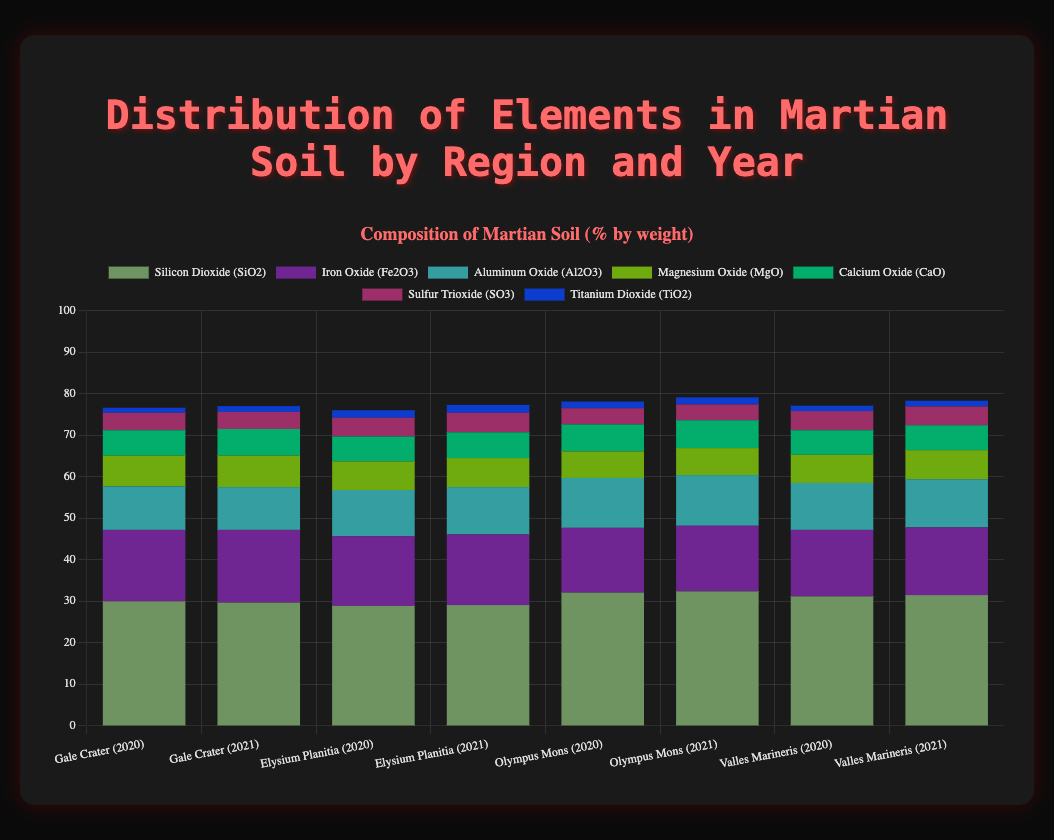What region and year have the highest percentage of Silicon Dioxide (SiO2)? Observing the bars in the figure, we look for the highest segment representing Silicon Dioxide (SiO2) across all regions and years. Olympus Mons in 2021 shows the highest percentage of Silicon Dioxide at 32.4%.
Answer: Olympus Mons, 2021 Which region has the most consistent percentage of Iron Oxide (Fe2O3) over the years? By checking the height of the Iron Oxide (Fe2O3) segments in all regions, we notice small variations in values for each region. Gale Crater has the most consistent percentages, with 17.2% in 2020 and 17.5% in 2021.
Answer: Gale Crater What is the total percentage of Magnesium Oxide (MgO) in Valles Marineris for both years combined? Summing up Magnesium Oxide (MgO) values in Valles Marineris for 2020 and 2021, we have 6.8% (2020) + 7.0% (2021) = 13.8%.
Answer: 13.8% Which region and year have the lowest percentage of Sulfur Trioxide (SO3)? Comparing the height of Sulfur Trioxide (SO3) segments across all bars, Olympus Mons in 2021 shows the lowest percentage at 3.8%.
Answer: Olympus Mons, 2021 By how much did the Aluminum Oxide (Al2O3) percentage change in Elysium Planitia from 2020 to 2021? Subtract the Aluminum Oxide (Al2O3) percentage in 2020 (11.1%) from the percentage in 2021 (11.4%). The change is 11.4% - 11.1% = 0.3%.
Answer: 0.3% What is the mean percentage of Calcium Oxide (CaO) in all regions for 2021? Calculate the mean by summing the Calcium Oxide (CaO) percentages for all regions in 2021 and dividing by the number of regions. The sum is 6.4% + 6.2% + 6.7% + 6.0% = 25.3%, and the mean is 25.3% / 4 = 6.325%.
Answer: 6.325% Which element has the highest mean percentage across all regions and years? Calculate the mean for each element by summing their percentages across all regions and years, then divide by the total number of observations (8). Silicon Dioxide (SiO2) has the highest mean at 30.7%.
Answer: Silicon Dioxide (SiO2) What is the combined percentage of Titanium Dioxide (TiO2) in Olympus Mons for both years? Add the Titanium Dioxide (TiO2) values in Olympus Mons for 2020 (1.6%) and 2021 (1.7%). The combined percentage is 1.6% + 1.7% = 3.3%.
Answer: 3.3% Compare the percentage of Silicon Dioxide (SiO2) in Valles Marineris between 2020 and 2021. Is there an increase or decrease? Check the Silicon Dioxide (SiO2) percentages for Valles Marineris in 2020 (31.2%) and 2021 (31.5%). There is an increase of 31.5% - 31.2% = 0.3%.
Answer: Increase What is the difference in the total percentage of Iron Oxide (Fe2O3) between Gale Crater and Valles Marineris in 2021? Subtract the Iron Oxide (Fe2O3) percentage in Valles Marineris (16.3%) from the percentage in Gale Crater (17.5%) for 2021. The difference is 17.5% - 16.3% = 1.2%.
Answer: 1.2% 